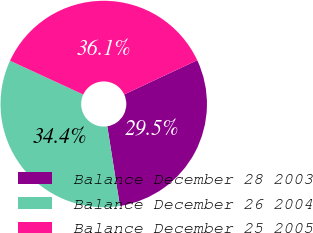Convert chart to OTSL. <chart><loc_0><loc_0><loc_500><loc_500><pie_chart><fcel>Balance December 28 2003<fcel>Balance December 26 2004<fcel>Balance December 25 2005<nl><fcel>29.47%<fcel>34.39%<fcel>36.14%<nl></chart> 